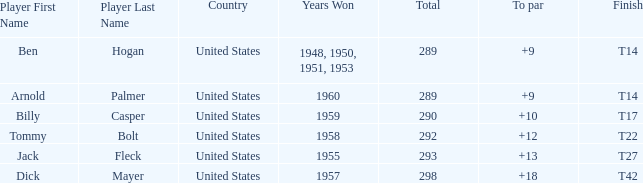What is Country, when Total is less than 290, and when Year(s) Won is 1960? United States. 